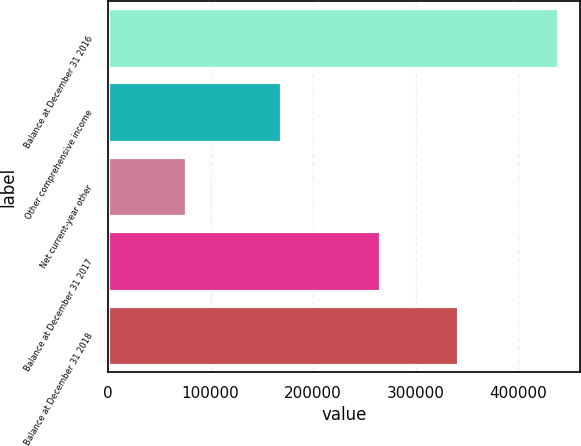<chart> <loc_0><loc_0><loc_500><loc_500><bar_chart><fcel>Balance at December 31 2016<fcel>Other comprehensive income<fcel>Net current-year other<fcel>Balance at December 31 2017<fcel>Balance at December 31 2018<nl><fcel>438717<fcel>169124<fcel>75994<fcel>265091<fcel>341085<nl></chart> 